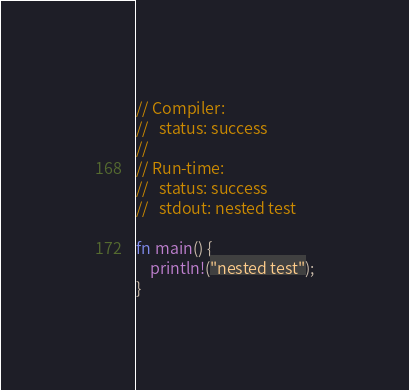Convert code to text. <code><loc_0><loc_0><loc_500><loc_500><_Rust_>// Compiler:
//   status: success
//
// Run-time:
//   status: success
//   stdout: nested test

fn main() {
    println!("nested test");
}
</code> 